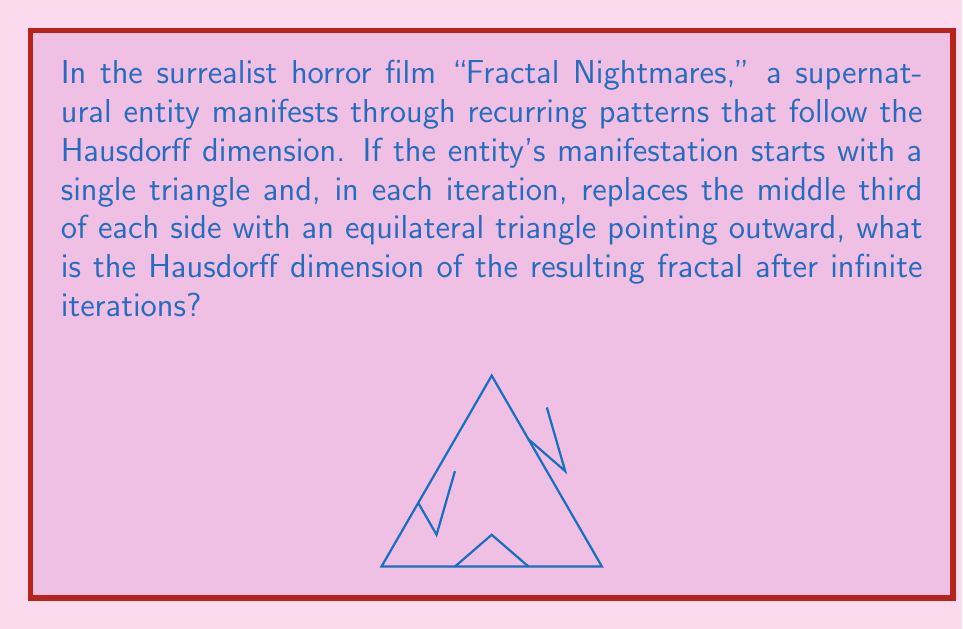Could you help me with this problem? To solve this problem, we need to understand the concept of the Hausdorff dimension and how it applies to self-similar fractals. The fractal described in the question is known as the Koch snowflake.

Step 1: Identify the scaling factor and the number of new pieces.
- In each iteration, each line segment is divided into 3 parts (scaling factor = 1/3)
- Each segment is replaced by 4 new segments (number of new pieces = 4)

Step 2: Apply the formula for the Hausdorff dimension (D) of a self-similar fractal:
$$ N = (\frac{1}{r})^D $$
Where:
N = number of new pieces
r = scaling factor
D = Hausdorff dimension

Step 3: Substitute the values into the formula:
$$ 4 = (\frac{1}{\frac{1}{3}})^D = 3^D $$

Step 4: Solve for D using logarithms:
$$ \log_3(4) = D $$

Step 5: Calculate the value:
$$ D = \frac{\log(4)}{\log(3)} \approx 1.2618595071429148 $$

This dimension is between 1 (a line) and 2 (a plane), reflecting the fractal's space-filling nature.
Answer: $\frac{\log(4)}{\log(3)}$ 